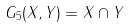Convert formula to latex. <formula><loc_0><loc_0><loc_500><loc_500>G _ { 5 } ( X , Y ) = X \cap Y</formula> 